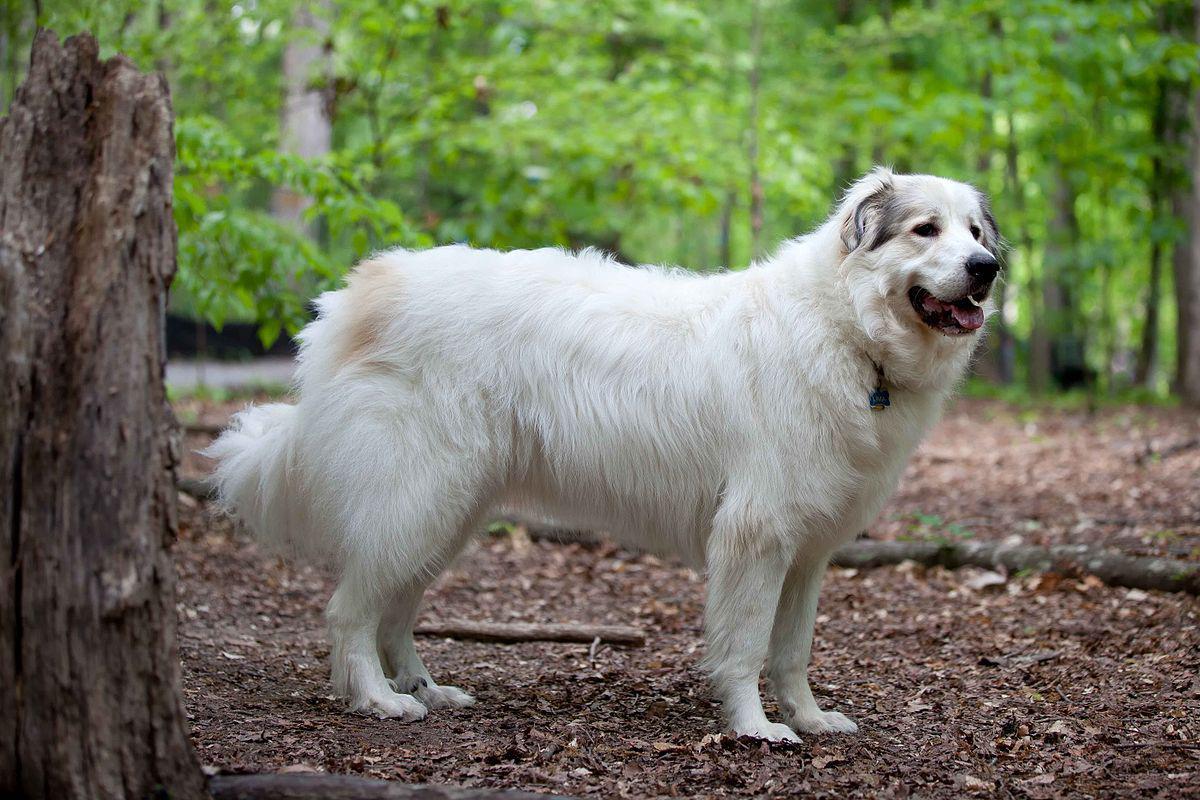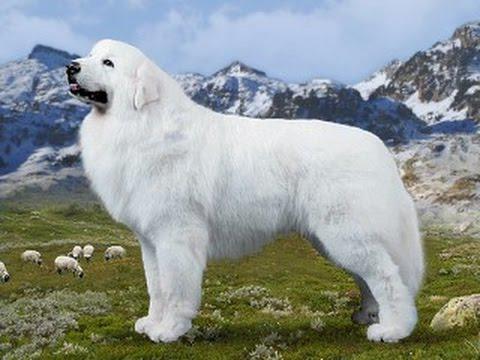The first image is the image on the left, the second image is the image on the right. Evaluate the accuracy of this statement regarding the images: "At least one of the dogs is with a human.". Is it true? Answer yes or no. No. 